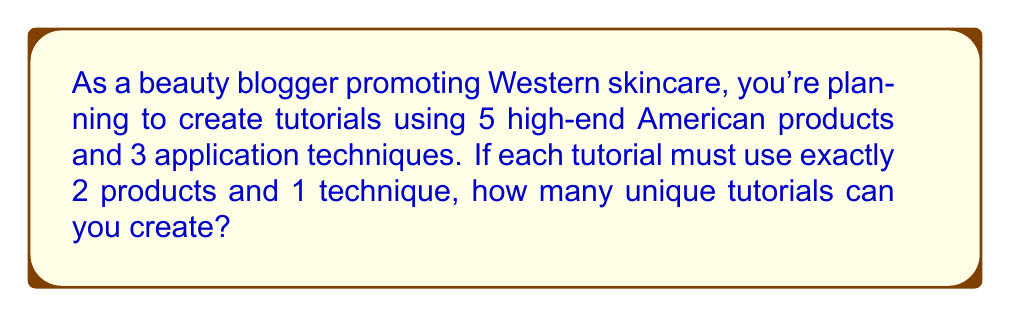Teach me how to tackle this problem. Let's approach this step-by-step:

1) First, we need to choose 2 products out of 5. This is a combination problem, denoted as $\binom{5}{2}$ or $C(5,2)$.

   $$\binom{5}{2} = \frac{5!}{2!(5-2)!} = \frac{5 \cdot 4}{2 \cdot 1} = 10$$

2) For each combination of 2 products, we need to choose 1 technique out of 3. This is simply 3 choices.

3) By the multiplication principle, the total number of unique tutorials is:

   $$10 \cdot 3 = 30$$

Therefore, you can create 30 unique tutorials using 2 products and 1 technique from your given set of Western skincare products and application techniques.
Answer: 30 